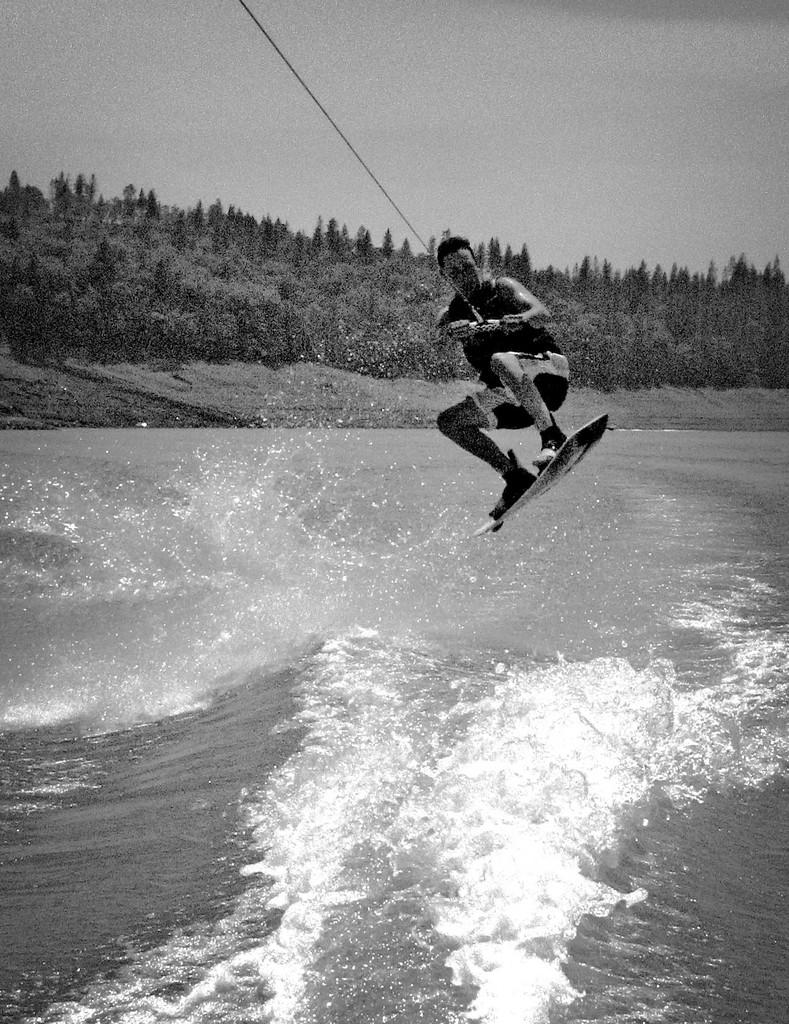What activity is the person in the image engaged in? The person is parasailing in the image. Where is the person located in the image? The person is in the center of the image. What is at the bottom of the image? There is a sea at the bottom of the image. What can be seen in the background of the image? There are trees and the sky visible in the background of the image. How many children are playing on the floor in the image? There are no children present in the image. The image features a person parasailing, not children playing on the floor. 